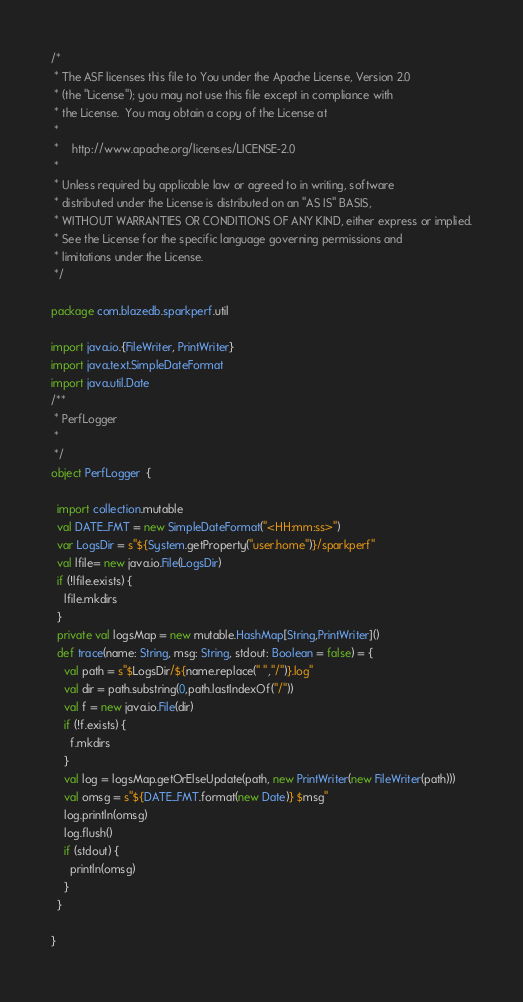<code> <loc_0><loc_0><loc_500><loc_500><_Scala_>/*
 * The ASF licenses this file to You under the Apache License, Version 2.0
 * (the "License"); you may not use this file except in compliance with
 * the License.  You may obtain a copy of the License at
 *
 *    http://www.apache.org/licenses/LICENSE-2.0
 *
 * Unless required by applicable law or agreed to in writing, software
 * distributed under the License is distributed on an "AS IS" BASIS,
 * WITHOUT WARRANTIES OR CONDITIONS OF ANY KIND, either express or implied.
 * See the License for the specific language governing permissions and
 * limitations under the License.
 */

package com.blazedb.sparkperf.util

import java.io.{FileWriter, PrintWriter}
import java.text.SimpleDateFormat
import java.util.Date
/**
 * PerfLogger
 *
 */
object PerfLogger  {

  import collection.mutable
  val DATE_FMT = new SimpleDateFormat("<HH:mm:ss>")
  var LogsDir = s"${System.getProperty("user.home")}/sparkperf"
  val lfile= new java.io.File(LogsDir)
  if (!lfile.exists) {
    lfile.mkdirs
  }
  private val logsMap = new mutable.HashMap[String,PrintWriter]()
  def trace(name: String, msg: String, stdout: Boolean = false) = {
    val path = s"$LogsDir/${name.replace(" ","/")}.log"
    val dir = path.substring(0,path.lastIndexOf("/"))
    val f = new java.io.File(dir)
    if (!f.exists) {
      f.mkdirs
    }
    val log = logsMap.getOrElseUpdate(path, new PrintWriter(new FileWriter(path)))
    val omsg = s"${DATE_FMT.format(new Date)} $msg"
    log.println(omsg)
    log.flush()
    if (stdout) {
      println(omsg)
    }
  }

}</code> 